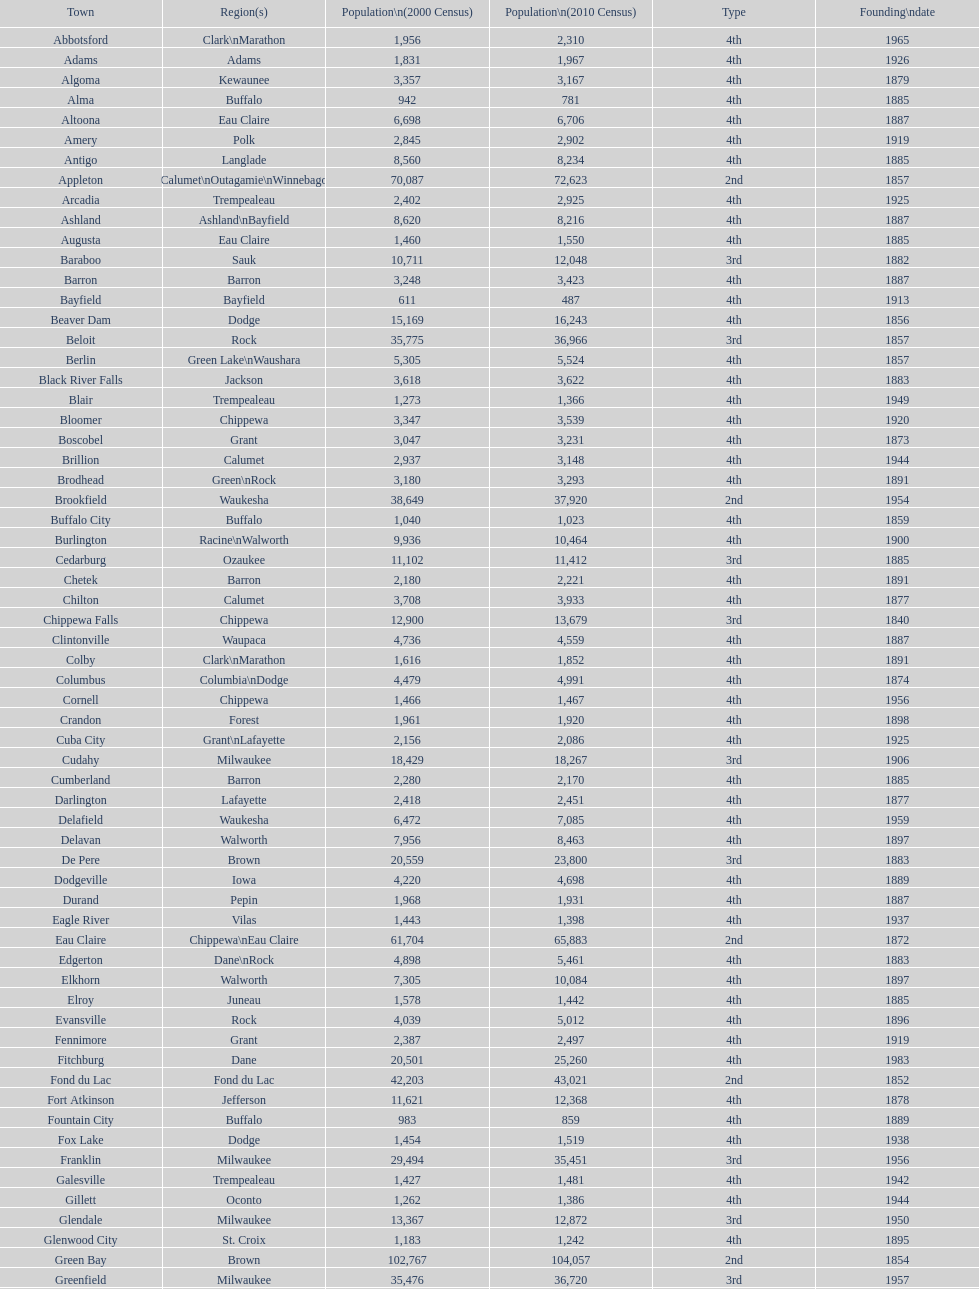Which city has the most population in the 2010 census? Milwaukee. 